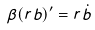Convert formula to latex. <formula><loc_0><loc_0><loc_500><loc_500>\beta ( r b ) ^ { \prime } = r \dot { b }</formula> 